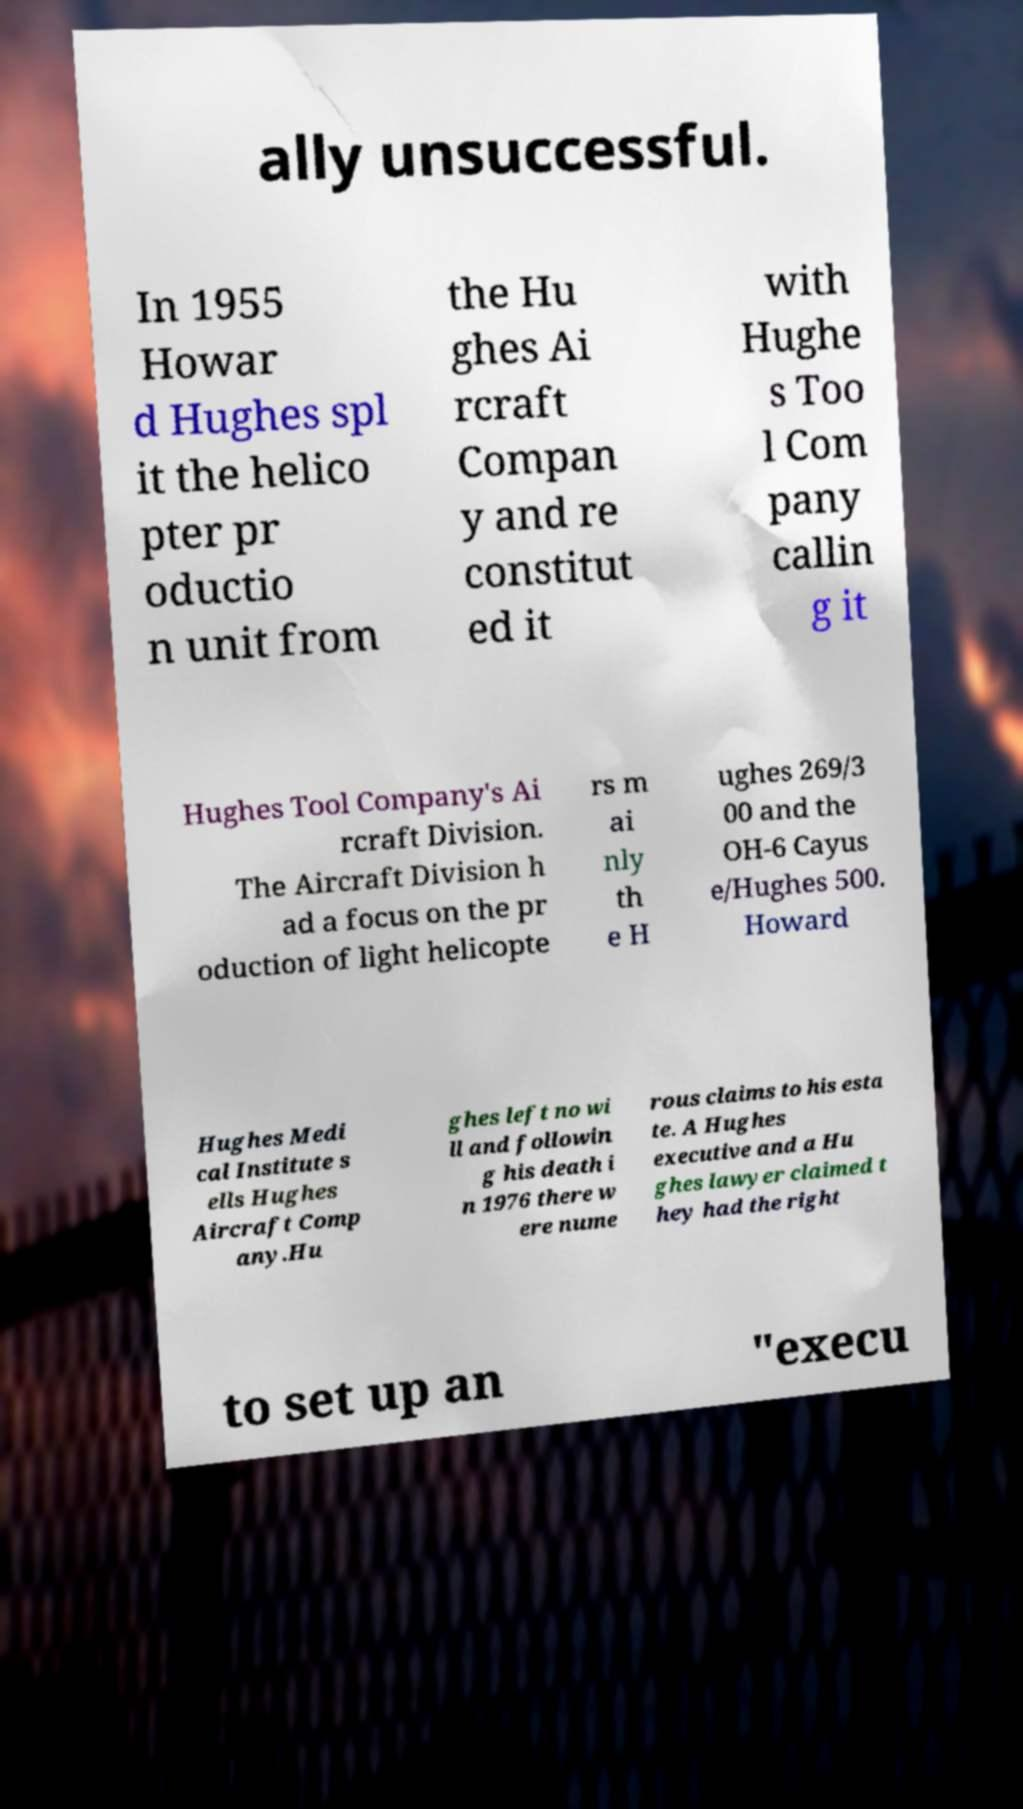Could you assist in decoding the text presented in this image and type it out clearly? ally unsuccessful. In 1955 Howar d Hughes spl it the helico pter pr oductio n unit from the Hu ghes Ai rcraft Compan y and re constitut ed it with Hughe s Too l Com pany callin g it Hughes Tool Company's Ai rcraft Division. The Aircraft Division h ad a focus on the pr oduction of light helicopte rs m ai nly th e H ughes 269/3 00 and the OH-6 Cayus e/Hughes 500. Howard Hughes Medi cal Institute s ells Hughes Aircraft Comp any.Hu ghes left no wi ll and followin g his death i n 1976 there w ere nume rous claims to his esta te. A Hughes executive and a Hu ghes lawyer claimed t hey had the right to set up an "execu 